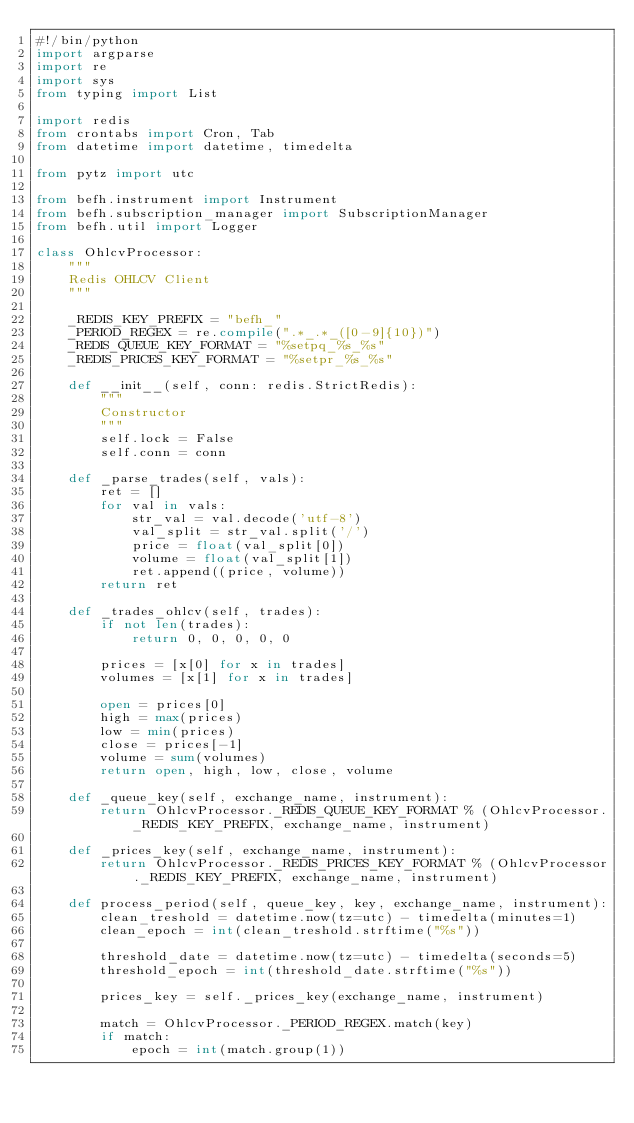Convert code to text. <code><loc_0><loc_0><loc_500><loc_500><_Python_>#!/bin/python
import argparse
import re
import sys
from typing import List

import redis
from crontabs import Cron, Tab
from datetime import datetime, timedelta

from pytz import utc

from befh.instrument import Instrument
from befh.subscription_manager import SubscriptionManager
from befh.util import Logger

class OhlcvProcessor:
    """
    Redis OHLCV Client
    """

    _REDIS_KEY_PREFIX = "befh_"
    _PERIOD_REGEX = re.compile(".*_.*_([0-9]{10})")
    _REDIS_QUEUE_KEY_FORMAT = "%setpq_%s_%s"
    _REDIS_PRICES_KEY_FORMAT = "%setpr_%s_%s"

    def __init__(self, conn: redis.StrictRedis):
        """
        Constructor
        """
        self.lock = False
        self.conn = conn

    def _parse_trades(self, vals):
        ret = []
        for val in vals:
            str_val = val.decode('utf-8')
            val_split = str_val.split('/')
            price = float(val_split[0])
            volume = float(val_split[1])
            ret.append((price, volume))
        return ret

    def _trades_ohlcv(self, trades):
        if not len(trades):
            return 0, 0, 0, 0, 0

        prices = [x[0] for x in trades]
        volumes = [x[1] for x in trades]

        open = prices[0]
        high = max(prices)
        low = min(prices)
        close = prices[-1]
        volume = sum(volumes)
        return open, high, low, close, volume

    def _queue_key(self, exchange_name, instrument):
        return OhlcvProcessor._REDIS_QUEUE_KEY_FORMAT % (OhlcvProcessor._REDIS_KEY_PREFIX, exchange_name, instrument)

    def _prices_key(self, exchange_name, instrument):
        return OhlcvProcessor._REDIS_PRICES_KEY_FORMAT % (OhlcvProcessor._REDIS_KEY_PREFIX, exchange_name, instrument)

    def process_period(self, queue_key, key, exchange_name, instrument):
        clean_treshold = datetime.now(tz=utc) - timedelta(minutes=1)
        clean_epoch = int(clean_treshold.strftime("%s"))

        threshold_date = datetime.now(tz=utc) - timedelta(seconds=5)
        threshold_epoch = int(threshold_date.strftime("%s"))

        prices_key = self._prices_key(exchange_name, instrument)

        match = OhlcvProcessor._PERIOD_REGEX.match(key)
        if match:
            epoch = int(match.group(1))</code> 